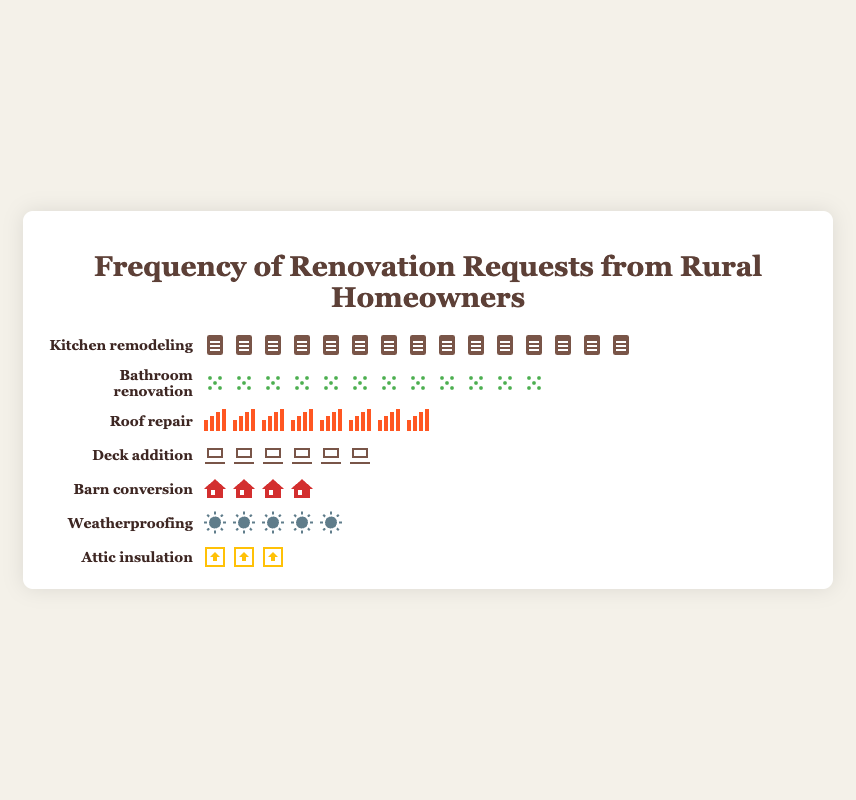What's the most requested renovation? To find the most requested renovation, identify which type has the highest number of icons in the figure. The kitchen remodeling row has 15 icons, the most among all types.
Answer: Kitchen remodeling Which renovation request is the least frequent? To determine the least frequent request, look for the row with the fewest icons in the figure. Attic insulation has only 3 icons, the lowest among all types.
Answer: Attic insulation How many more requests are there for bathroom renovations compared to roof repairs? Count the icons for bathroom renovations (12) and roof repairs (8). Subtract the number of roof repair icons from bathroom renovation icons: 12 - 8 = 4.
Answer: 4 What is the total number of renovation requests? Add up the icons for all renovation types: 15 (kitchen) + 12 (bathroom) + 8 (roof) + 6 (deck) + 4 (barn) + 5 (weatherproofing) + 3 (attic). The sum is 53.
Answer: 53 How many total requests are there for deck additions and barn conversions combined? Count the icons for deck additions (6) and barn conversions (4). Add them together: 6 + 4 = 10.
Answer: 10 Which has a higher frequency: Weatherproofing or Deck addition? Compare the number of icons for weatherproofing (5) and deck addition (6). Deck addition has more icons.
Answer: Deck addition What is the combined frequency of the three least requested renovations? Identify the least requested renovations: attic insulation (3), barn conversion (4), and weatherproofing (5). Add them together: 3 + 4 + 5 = 12.
Answer: 12 How many bathroom renovation requests are there compared to kitchen remodeling requests? Count the icons for bathroom renovations (12) and kitchen remodeling (15). Bathroom renovations have 3 fewer requests than kitchen remodeling: 15 - 12 = 3.
Answer: 3 Which type of request shows more than double the frequency compared to attic insulation? Attic insulation has 3 icons. Check renovation types with double that frequency (2 × 3 = 6). Both kitchen remodeling (15), bathroom renovation (12), roof repair (8), and deck addition (6) meet this criterion.
Answer: Kitchen remodeling, Bathroom renovation, Roof repair, Deck addition What fraction of the requests are for roof repair? Count the total number of requests (53). Roof repair has 8 requests. The fraction is 8/53. Simplifying is not necessary for an exact representation.
Answer: 8/53 